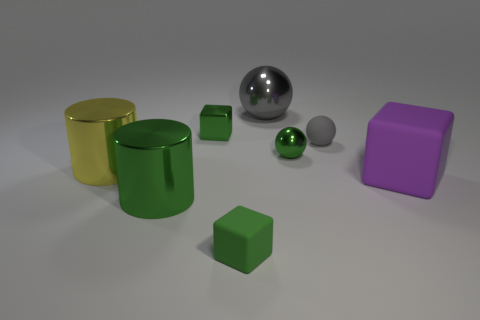What is the color of the ball that is the same size as the yellow cylinder?
Your answer should be compact. Gray. There is a small matte ball; is its color the same as the cylinder in front of the big purple matte block?
Offer a terse response. No. What color is the tiny rubber sphere?
Offer a terse response. Gray. What is the material of the gray ball on the right side of the gray shiny sphere?
Your response must be concise. Rubber. There is a green shiny thing that is the same shape as the large purple object; what is its size?
Provide a succinct answer. Small. Are there fewer large purple things that are behind the yellow thing than tiny blue metallic balls?
Keep it short and to the point. No. Are any big blue metallic blocks visible?
Offer a very short reply. No. There is another thing that is the same shape as the large green object; what color is it?
Keep it short and to the point. Yellow. There is a sphere that is behind the matte ball; is its color the same as the large matte block?
Offer a terse response. No. Is the size of the yellow object the same as the gray rubber sphere?
Your answer should be compact. No. 